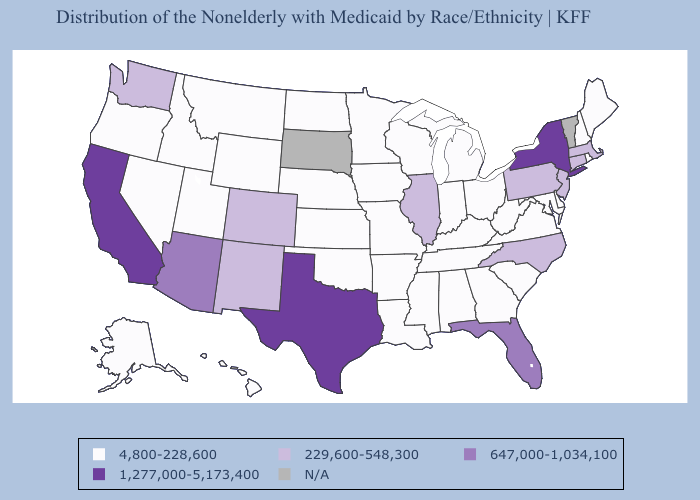What is the value of California?
Concise answer only. 1,277,000-5,173,400. Which states have the lowest value in the MidWest?
Quick response, please. Indiana, Iowa, Kansas, Michigan, Minnesota, Missouri, Nebraska, North Dakota, Ohio, Wisconsin. Does Connecticut have the lowest value in the USA?
Concise answer only. No. Does California have the highest value in the West?
Keep it brief. Yes. Which states have the highest value in the USA?
Answer briefly. California, New York, Texas. Name the states that have a value in the range 4,800-228,600?
Keep it brief. Alabama, Alaska, Arkansas, Delaware, Georgia, Hawaii, Idaho, Indiana, Iowa, Kansas, Kentucky, Louisiana, Maine, Maryland, Michigan, Minnesota, Mississippi, Missouri, Montana, Nebraska, Nevada, New Hampshire, North Dakota, Ohio, Oklahoma, Oregon, Rhode Island, South Carolina, Tennessee, Utah, Virginia, West Virginia, Wisconsin, Wyoming. What is the lowest value in the USA?
Give a very brief answer. 4,800-228,600. What is the value of Alaska?
Quick response, please. 4,800-228,600. What is the value of California?
Answer briefly. 1,277,000-5,173,400. Name the states that have a value in the range 647,000-1,034,100?
Quick response, please. Arizona, Florida. What is the value of Arizona?
Answer briefly. 647,000-1,034,100. Which states have the highest value in the USA?
Give a very brief answer. California, New York, Texas. Does New York have the highest value in the USA?
Give a very brief answer. Yes. Does the map have missing data?
Keep it brief. Yes. 